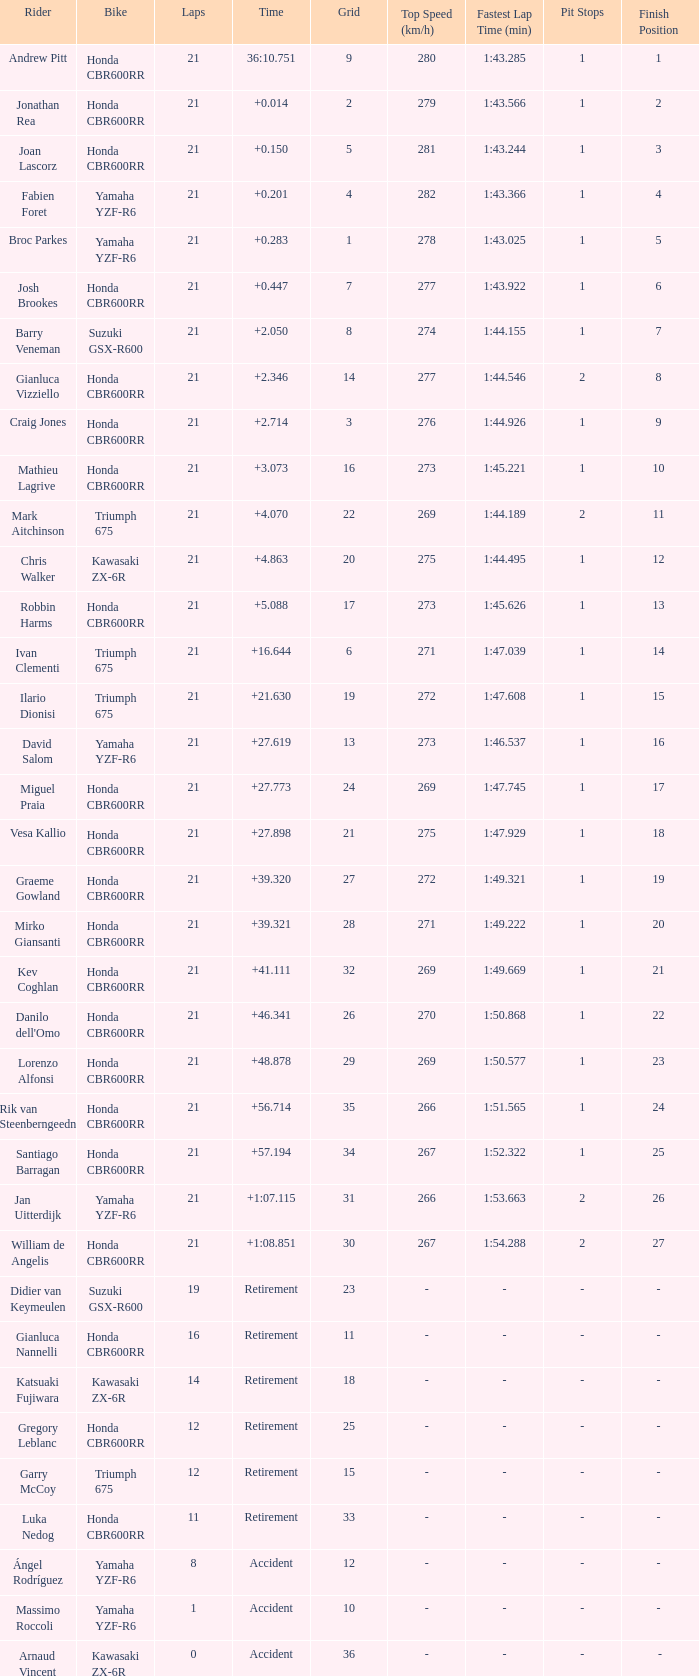What is the total of laps run by the driver with a grid under 17 and a time of +5.088? None. 